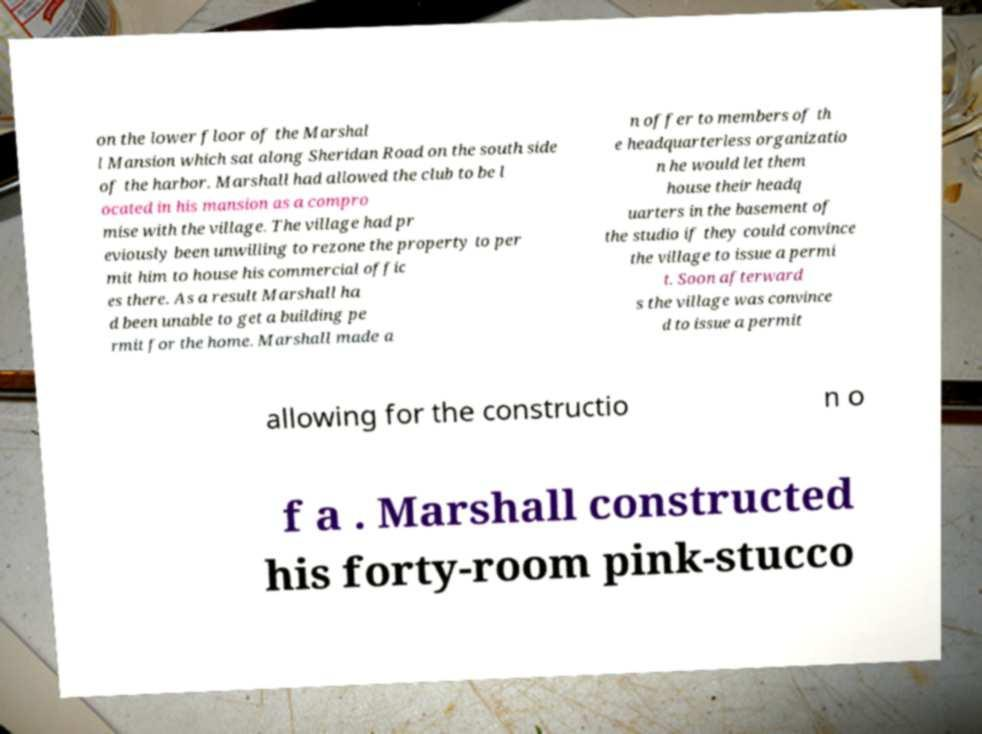Please identify and transcribe the text found in this image. on the lower floor of the Marshal l Mansion which sat along Sheridan Road on the south side of the harbor. Marshall had allowed the club to be l ocated in his mansion as a compro mise with the village. The village had pr eviously been unwilling to rezone the property to per mit him to house his commercial offic es there. As a result Marshall ha d been unable to get a building pe rmit for the home. Marshall made a n offer to members of th e headquarterless organizatio n he would let them house their headq uarters in the basement of the studio if they could convince the village to issue a permi t. Soon afterward s the village was convince d to issue a permit allowing for the constructio n o f a . Marshall constructed his forty-room pink-stucco 